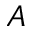<formula> <loc_0><loc_0><loc_500><loc_500>A</formula> 